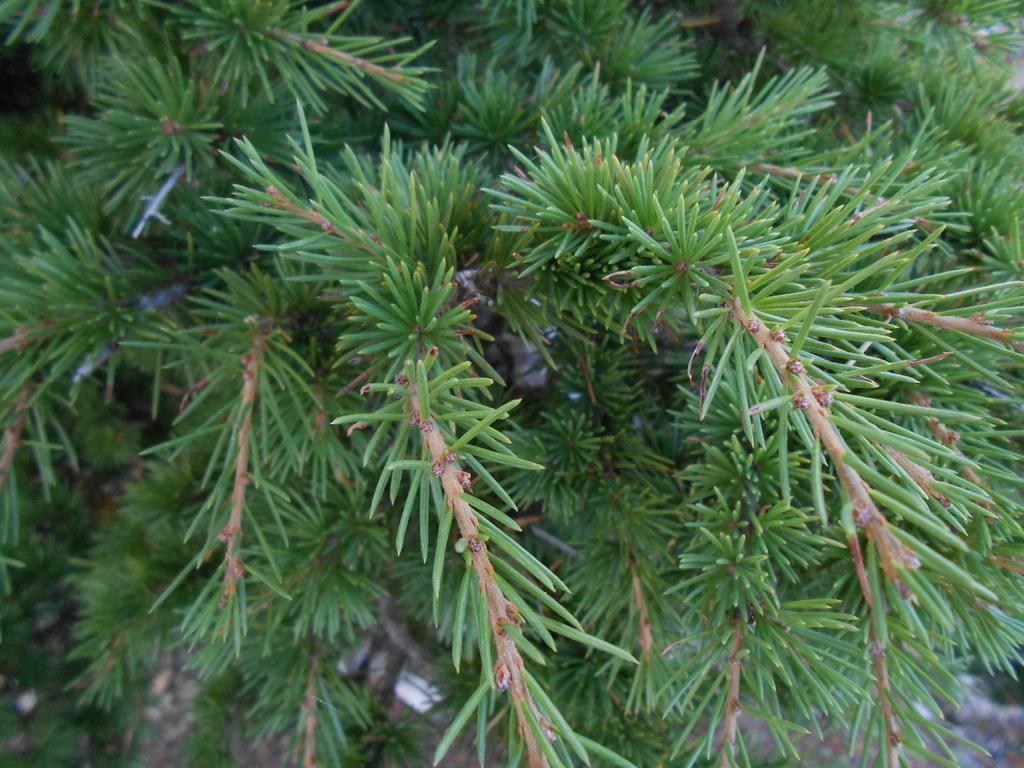In one or two sentences, can you explain what this image depicts? There are branches of tree with leaves. 